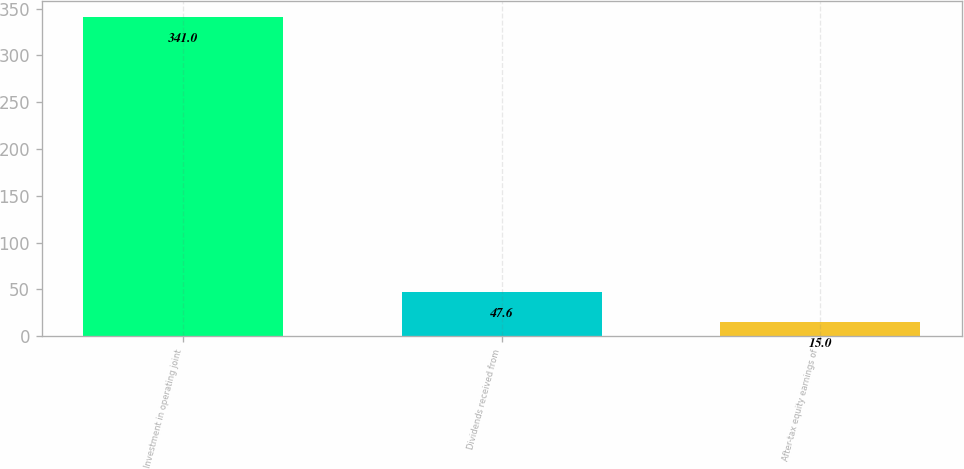Convert chart to OTSL. <chart><loc_0><loc_0><loc_500><loc_500><bar_chart><fcel>Investment in operating joint<fcel>Dividends received from<fcel>After-tax equity earnings of<nl><fcel>341<fcel>47.6<fcel>15<nl></chart> 